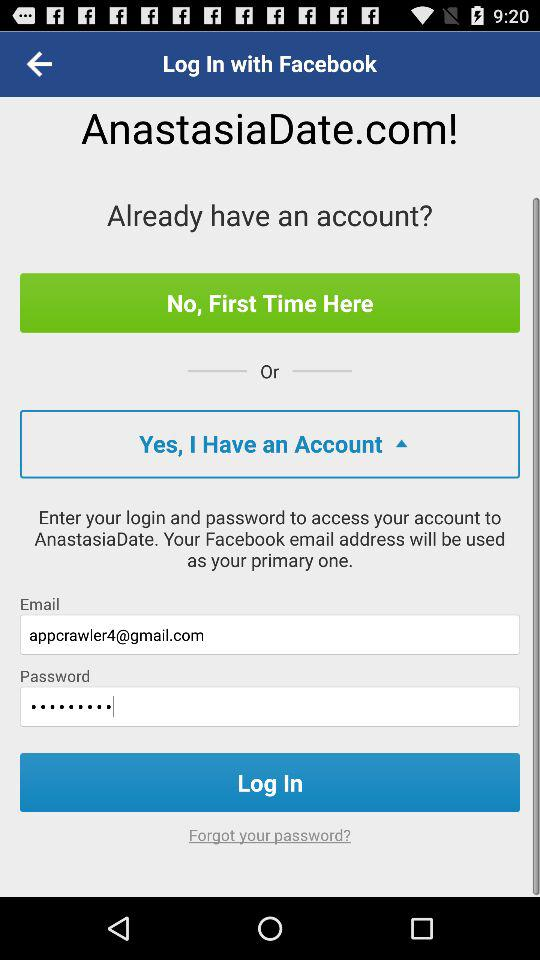How many text inputs are on the screen?
Answer the question using a single word or phrase. 2 